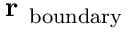Convert formula to latex. <formula><loc_0><loc_0><loc_500><loc_500>r _ { b o u n d a r y }</formula> 